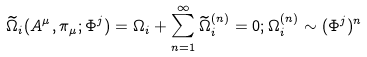<formula> <loc_0><loc_0><loc_500><loc_500>\widetilde { \Omega } _ { i } ( A ^ { \mu } , \pi _ { \mu } ; \Phi ^ { j } ) = \Omega _ { i } + \sum _ { n = 1 } ^ { \infty } \widetilde { \Omega } _ { i } ^ { ( n ) } = 0 ; \Omega _ { i } ^ { ( n ) } \sim ( \Phi ^ { j } ) ^ { n }</formula> 